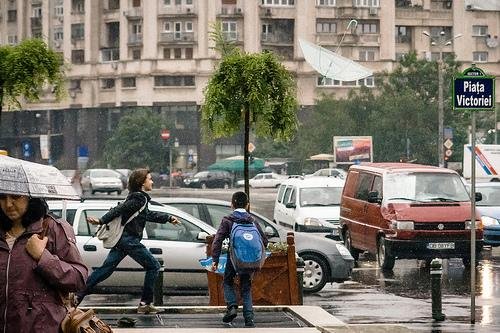Provide a brief emotional analysis of the image based on the objects and actions presented. Busy with a mix of caution and urgency as people and vehicles navigate a bustling city street in what seems to be a rainy day. Mention any environmental or weather-related features in the image. A green plant, the leaves are green, a tree in the middle of the city, a small green tree growing in a large planter, a wooden planter, and a woman with an umbrella. Describe any interactions between objects in the image that involve a backpack. A blue and grey backpack on a little boy's back; a young boy wearing a blue backpack; and a boy wearing a white backpack running. Identify the primary action happening in the image. A person running in the street, a child crossing the street, and a woman holding an umbrella. Estimate the number of streetlights present in the image. There is one overhead street light. Name three objects in the image that have the color red. A red van, a red do not enter sign, and a dark red van that has been wrecked. List any objects that are found flying in the image. An umbrella flying in the air and an upside-down umbrella in the air. What color is the van that is driving down the road? The van driving down the road is brown. Describe any road signs present in the image. A red do not enter sign, a green and blue street sign, and a black sign with white letters. How many vehicles are present in the picture? Include parked and moving ones. There are six vehicles: a red van, a white van, a parked black car, a back of a white delivery van, a black SUV parked across the street, and a big red van driving down the street. Detect any unusual objects or events in the image. An upside-down umbrella flying in the air. Evaluate the clarity and visual appeal of the image. The image is clear and visually appealing. Ground the phrase "billboard in the distance" within the image. X:331 Y:134 Width:42 Height:42 Express the sentiment of the image. Busy, energetic Are there birds flying above the overhead street light? There is no information about birds being present in the image, let alone flying above the overhead street light. What is the color of the van following the brown van? White Can you see a cat sitting on the hood of the parked black car? There is no information about a cat being present in the image, let alone sitting on the hood of the parked black car. What is the relationship between the white van and the red do not enter sign? The white van is driving down the street, with the red do not enter sign positioned by the side of the road. Describe the person running in the street. A person wearing a dark-colored jacket is running in the street. Describe the texture of the dark red van. Wrecked Is the white emblem on the backpack round or square in shape? Round Determine the primary color of the boy's backpack. Blue What does the green and blue street sign say? Unable to read text from the image. Is the woman with the umbrella wearing a yellow hat? There is no information about the woman with the umbrella wearing a hat, let alone a yellow one. How many captions are available for the red van? 4 Which vehicle is the closest to the brown van: the white van or the parked black car? White van Identify any text present in the image. Green and blue street sign with white letters. Is the boy wearing white backpack running in the park? The situation of the boy running is described but without a location like a park being mentioned. Locate the person wearing a backpack in the image. X:230 Y:223 Width:43 Height:43 Identify the different objects in the image. People, vehicles, street sign, planter, billboard, street light, building, umbrella. Find any anomalies with the green plant in the image. No anomalies detected. What is the predominant emotion conveyed by the image? Energetic Is there a green banner next to the billboard in the distance? The image only mentions a billboard in the distance, but doesn't mention anything about a green banner next to it. Examine the interaction between the children and the woman with an umbrella. The children are on the sidewalk while the woman with an umbrella is walking to their left. Does the red do not enter sign have a picture of a hand on it? There's only a mention of a red do not enter sign, but no mention of a hand on it. 